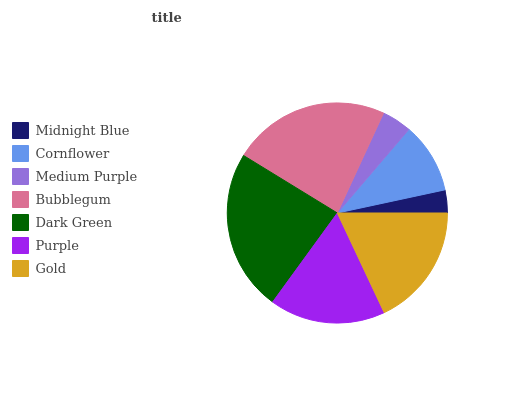Is Midnight Blue the minimum?
Answer yes or no. Yes. Is Dark Green the maximum?
Answer yes or no. Yes. Is Cornflower the minimum?
Answer yes or no. No. Is Cornflower the maximum?
Answer yes or no. No. Is Cornflower greater than Midnight Blue?
Answer yes or no. Yes. Is Midnight Blue less than Cornflower?
Answer yes or no. Yes. Is Midnight Blue greater than Cornflower?
Answer yes or no. No. Is Cornflower less than Midnight Blue?
Answer yes or no. No. Is Purple the high median?
Answer yes or no. Yes. Is Purple the low median?
Answer yes or no. Yes. Is Midnight Blue the high median?
Answer yes or no. No. Is Bubblegum the low median?
Answer yes or no. No. 